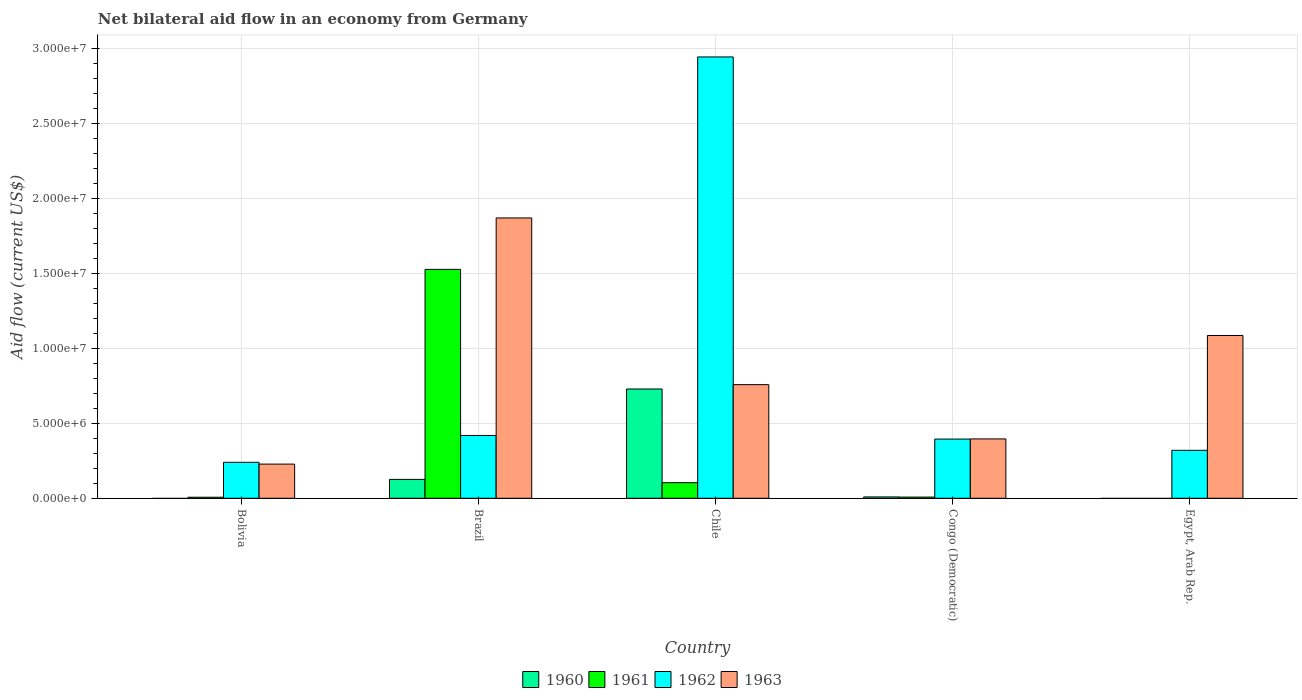How many different coloured bars are there?
Ensure brevity in your answer.  4. How many bars are there on the 3rd tick from the left?
Offer a terse response. 4. How many bars are there on the 4th tick from the right?
Provide a short and direct response. 4. What is the label of the 2nd group of bars from the left?
Keep it short and to the point. Brazil. In how many cases, is the number of bars for a given country not equal to the number of legend labels?
Your answer should be very brief. 2. What is the net bilateral aid flow in 1960 in Brazil?
Give a very brief answer. 1.26e+06. Across all countries, what is the maximum net bilateral aid flow in 1960?
Your answer should be very brief. 7.29e+06. Across all countries, what is the minimum net bilateral aid flow in 1960?
Your answer should be compact. 0. In which country was the net bilateral aid flow in 1962 maximum?
Your answer should be compact. Chile. What is the total net bilateral aid flow in 1963 in the graph?
Make the answer very short. 4.34e+07. What is the difference between the net bilateral aid flow in 1962 in Brazil and that in Egypt, Arab Rep.?
Keep it short and to the point. 9.90e+05. What is the difference between the net bilateral aid flow in 1961 in Chile and the net bilateral aid flow in 1963 in Egypt, Arab Rep.?
Ensure brevity in your answer.  -9.82e+06. What is the average net bilateral aid flow in 1963 per country?
Provide a short and direct response. 8.68e+06. What is the difference between the net bilateral aid flow of/in 1962 and net bilateral aid flow of/in 1961 in Chile?
Your answer should be very brief. 2.84e+07. In how many countries, is the net bilateral aid flow in 1961 greater than 16000000 US$?
Offer a terse response. 0. Is the net bilateral aid flow in 1962 in Congo (Democratic) less than that in Egypt, Arab Rep.?
Provide a succinct answer. No. Is the difference between the net bilateral aid flow in 1962 in Bolivia and Brazil greater than the difference between the net bilateral aid flow in 1961 in Bolivia and Brazil?
Your response must be concise. Yes. What is the difference between the highest and the second highest net bilateral aid flow in 1960?
Provide a succinct answer. 7.20e+06. What is the difference between the highest and the lowest net bilateral aid flow in 1962?
Your answer should be very brief. 2.70e+07. Is it the case that in every country, the sum of the net bilateral aid flow in 1962 and net bilateral aid flow in 1960 is greater than the net bilateral aid flow in 1963?
Ensure brevity in your answer.  No. How many countries are there in the graph?
Offer a terse response. 5. Does the graph contain any zero values?
Your answer should be compact. Yes. Where does the legend appear in the graph?
Your answer should be compact. Bottom center. How are the legend labels stacked?
Keep it short and to the point. Horizontal. What is the title of the graph?
Your answer should be compact. Net bilateral aid flow in an economy from Germany. Does "2012" appear as one of the legend labels in the graph?
Provide a succinct answer. No. What is the label or title of the Y-axis?
Offer a terse response. Aid flow (current US$). What is the Aid flow (current US$) of 1961 in Bolivia?
Ensure brevity in your answer.  7.00e+04. What is the Aid flow (current US$) of 1962 in Bolivia?
Your answer should be compact. 2.40e+06. What is the Aid flow (current US$) of 1963 in Bolivia?
Ensure brevity in your answer.  2.28e+06. What is the Aid flow (current US$) in 1960 in Brazil?
Ensure brevity in your answer.  1.26e+06. What is the Aid flow (current US$) in 1961 in Brazil?
Offer a very short reply. 1.53e+07. What is the Aid flow (current US$) of 1962 in Brazil?
Your response must be concise. 4.19e+06. What is the Aid flow (current US$) of 1963 in Brazil?
Provide a short and direct response. 1.87e+07. What is the Aid flow (current US$) in 1960 in Chile?
Keep it short and to the point. 7.29e+06. What is the Aid flow (current US$) in 1961 in Chile?
Provide a succinct answer. 1.04e+06. What is the Aid flow (current US$) of 1962 in Chile?
Provide a short and direct response. 2.94e+07. What is the Aid flow (current US$) of 1963 in Chile?
Keep it short and to the point. 7.58e+06. What is the Aid flow (current US$) of 1962 in Congo (Democratic)?
Provide a short and direct response. 3.95e+06. What is the Aid flow (current US$) of 1963 in Congo (Democratic)?
Offer a very short reply. 3.96e+06. What is the Aid flow (current US$) of 1961 in Egypt, Arab Rep.?
Offer a terse response. 0. What is the Aid flow (current US$) in 1962 in Egypt, Arab Rep.?
Offer a terse response. 3.20e+06. What is the Aid flow (current US$) in 1963 in Egypt, Arab Rep.?
Give a very brief answer. 1.09e+07. Across all countries, what is the maximum Aid flow (current US$) in 1960?
Provide a succinct answer. 7.29e+06. Across all countries, what is the maximum Aid flow (current US$) of 1961?
Provide a short and direct response. 1.53e+07. Across all countries, what is the maximum Aid flow (current US$) in 1962?
Your response must be concise. 2.94e+07. Across all countries, what is the maximum Aid flow (current US$) of 1963?
Your answer should be very brief. 1.87e+07. Across all countries, what is the minimum Aid flow (current US$) in 1960?
Offer a very short reply. 0. Across all countries, what is the minimum Aid flow (current US$) of 1961?
Your answer should be compact. 0. Across all countries, what is the minimum Aid flow (current US$) of 1962?
Keep it short and to the point. 2.40e+06. Across all countries, what is the minimum Aid flow (current US$) of 1963?
Offer a terse response. 2.28e+06. What is the total Aid flow (current US$) of 1960 in the graph?
Ensure brevity in your answer.  8.64e+06. What is the total Aid flow (current US$) in 1961 in the graph?
Provide a short and direct response. 1.65e+07. What is the total Aid flow (current US$) of 1962 in the graph?
Give a very brief answer. 4.32e+07. What is the total Aid flow (current US$) of 1963 in the graph?
Offer a very short reply. 4.34e+07. What is the difference between the Aid flow (current US$) of 1961 in Bolivia and that in Brazil?
Offer a terse response. -1.52e+07. What is the difference between the Aid flow (current US$) in 1962 in Bolivia and that in Brazil?
Provide a short and direct response. -1.79e+06. What is the difference between the Aid flow (current US$) of 1963 in Bolivia and that in Brazil?
Offer a very short reply. -1.64e+07. What is the difference between the Aid flow (current US$) of 1961 in Bolivia and that in Chile?
Your answer should be very brief. -9.70e+05. What is the difference between the Aid flow (current US$) of 1962 in Bolivia and that in Chile?
Provide a succinct answer. -2.70e+07. What is the difference between the Aid flow (current US$) of 1963 in Bolivia and that in Chile?
Provide a succinct answer. -5.30e+06. What is the difference between the Aid flow (current US$) in 1962 in Bolivia and that in Congo (Democratic)?
Provide a short and direct response. -1.55e+06. What is the difference between the Aid flow (current US$) of 1963 in Bolivia and that in Congo (Democratic)?
Keep it short and to the point. -1.68e+06. What is the difference between the Aid flow (current US$) in 1962 in Bolivia and that in Egypt, Arab Rep.?
Offer a terse response. -8.00e+05. What is the difference between the Aid flow (current US$) of 1963 in Bolivia and that in Egypt, Arab Rep.?
Ensure brevity in your answer.  -8.58e+06. What is the difference between the Aid flow (current US$) in 1960 in Brazil and that in Chile?
Offer a very short reply. -6.03e+06. What is the difference between the Aid flow (current US$) of 1961 in Brazil and that in Chile?
Provide a short and direct response. 1.42e+07. What is the difference between the Aid flow (current US$) in 1962 in Brazil and that in Chile?
Ensure brevity in your answer.  -2.52e+07. What is the difference between the Aid flow (current US$) in 1963 in Brazil and that in Chile?
Your answer should be very brief. 1.11e+07. What is the difference between the Aid flow (current US$) in 1960 in Brazil and that in Congo (Democratic)?
Your answer should be compact. 1.17e+06. What is the difference between the Aid flow (current US$) in 1961 in Brazil and that in Congo (Democratic)?
Your answer should be very brief. 1.52e+07. What is the difference between the Aid flow (current US$) of 1963 in Brazil and that in Congo (Democratic)?
Ensure brevity in your answer.  1.47e+07. What is the difference between the Aid flow (current US$) in 1962 in Brazil and that in Egypt, Arab Rep.?
Provide a short and direct response. 9.90e+05. What is the difference between the Aid flow (current US$) of 1963 in Brazil and that in Egypt, Arab Rep.?
Keep it short and to the point. 7.84e+06. What is the difference between the Aid flow (current US$) in 1960 in Chile and that in Congo (Democratic)?
Give a very brief answer. 7.20e+06. What is the difference between the Aid flow (current US$) of 1961 in Chile and that in Congo (Democratic)?
Ensure brevity in your answer.  9.60e+05. What is the difference between the Aid flow (current US$) in 1962 in Chile and that in Congo (Democratic)?
Your response must be concise. 2.55e+07. What is the difference between the Aid flow (current US$) of 1963 in Chile and that in Congo (Democratic)?
Provide a succinct answer. 3.62e+06. What is the difference between the Aid flow (current US$) in 1962 in Chile and that in Egypt, Arab Rep.?
Offer a very short reply. 2.62e+07. What is the difference between the Aid flow (current US$) of 1963 in Chile and that in Egypt, Arab Rep.?
Keep it short and to the point. -3.28e+06. What is the difference between the Aid flow (current US$) of 1962 in Congo (Democratic) and that in Egypt, Arab Rep.?
Ensure brevity in your answer.  7.50e+05. What is the difference between the Aid flow (current US$) of 1963 in Congo (Democratic) and that in Egypt, Arab Rep.?
Offer a very short reply. -6.90e+06. What is the difference between the Aid flow (current US$) of 1961 in Bolivia and the Aid flow (current US$) of 1962 in Brazil?
Offer a very short reply. -4.12e+06. What is the difference between the Aid flow (current US$) of 1961 in Bolivia and the Aid flow (current US$) of 1963 in Brazil?
Keep it short and to the point. -1.86e+07. What is the difference between the Aid flow (current US$) in 1962 in Bolivia and the Aid flow (current US$) in 1963 in Brazil?
Your answer should be very brief. -1.63e+07. What is the difference between the Aid flow (current US$) in 1961 in Bolivia and the Aid flow (current US$) in 1962 in Chile?
Ensure brevity in your answer.  -2.94e+07. What is the difference between the Aid flow (current US$) of 1961 in Bolivia and the Aid flow (current US$) of 1963 in Chile?
Your answer should be compact. -7.51e+06. What is the difference between the Aid flow (current US$) in 1962 in Bolivia and the Aid flow (current US$) in 1963 in Chile?
Give a very brief answer. -5.18e+06. What is the difference between the Aid flow (current US$) of 1961 in Bolivia and the Aid flow (current US$) of 1962 in Congo (Democratic)?
Provide a succinct answer. -3.88e+06. What is the difference between the Aid flow (current US$) of 1961 in Bolivia and the Aid flow (current US$) of 1963 in Congo (Democratic)?
Give a very brief answer. -3.89e+06. What is the difference between the Aid flow (current US$) of 1962 in Bolivia and the Aid flow (current US$) of 1963 in Congo (Democratic)?
Offer a very short reply. -1.56e+06. What is the difference between the Aid flow (current US$) in 1961 in Bolivia and the Aid flow (current US$) in 1962 in Egypt, Arab Rep.?
Provide a succinct answer. -3.13e+06. What is the difference between the Aid flow (current US$) of 1961 in Bolivia and the Aid flow (current US$) of 1963 in Egypt, Arab Rep.?
Keep it short and to the point. -1.08e+07. What is the difference between the Aid flow (current US$) of 1962 in Bolivia and the Aid flow (current US$) of 1963 in Egypt, Arab Rep.?
Your answer should be very brief. -8.46e+06. What is the difference between the Aid flow (current US$) of 1960 in Brazil and the Aid flow (current US$) of 1962 in Chile?
Offer a terse response. -2.82e+07. What is the difference between the Aid flow (current US$) in 1960 in Brazil and the Aid flow (current US$) in 1963 in Chile?
Offer a very short reply. -6.32e+06. What is the difference between the Aid flow (current US$) in 1961 in Brazil and the Aid flow (current US$) in 1962 in Chile?
Give a very brief answer. -1.42e+07. What is the difference between the Aid flow (current US$) of 1961 in Brazil and the Aid flow (current US$) of 1963 in Chile?
Your answer should be compact. 7.69e+06. What is the difference between the Aid flow (current US$) in 1962 in Brazil and the Aid flow (current US$) in 1963 in Chile?
Your answer should be very brief. -3.39e+06. What is the difference between the Aid flow (current US$) of 1960 in Brazil and the Aid flow (current US$) of 1961 in Congo (Democratic)?
Provide a short and direct response. 1.18e+06. What is the difference between the Aid flow (current US$) in 1960 in Brazil and the Aid flow (current US$) in 1962 in Congo (Democratic)?
Offer a very short reply. -2.69e+06. What is the difference between the Aid flow (current US$) of 1960 in Brazil and the Aid flow (current US$) of 1963 in Congo (Democratic)?
Provide a succinct answer. -2.70e+06. What is the difference between the Aid flow (current US$) of 1961 in Brazil and the Aid flow (current US$) of 1962 in Congo (Democratic)?
Your response must be concise. 1.13e+07. What is the difference between the Aid flow (current US$) in 1961 in Brazil and the Aid flow (current US$) in 1963 in Congo (Democratic)?
Ensure brevity in your answer.  1.13e+07. What is the difference between the Aid flow (current US$) of 1962 in Brazil and the Aid flow (current US$) of 1963 in Congo (Democratic)?
Provide a short and direct response. 2.30e+05. What is the difference between the Aid flow (current US$) in 1960 in Brazil and the Aid flow (current US$) in 1962 in Egypt, Arab Rep.?
Make the answer very short. -1.94e+06. What is the difference between the Aid flow (current US$) of 1960 in Brazil and the Aid flow (current US$) of 1963 in Egypt, Arab Rep.?
Provide a short and direct response. -9.60e+06. What is the difference between the Aid flow (current US$) in 1961 in Brazil and the Aid flow (current US$) in 1962 in Egypt, Arab Rep.?
Give a very brief answer. 1.21e+07. What is the difference between the Aid flow (current US$) in 1961 in Brazil and the Aid flow (current US$) in 1963 in Egypt, Arab Rep.?
Give a very brief answer. 4.41e+06. What is the difference between the Aid flow (current US$) of 1962 in Brazil and the Aid flow (current US$) of 1963 in Egypt, Arab Rep.?
Offer a very short reply. -6.67e+06. What is the difference between the Aid flow (current US$) of 1960 in Chile and the Aid flow (current US$) of 1961 in Congo (Democratic)?
Keep it short and to the point. 7.21e+06. What is the difference between the Aid flow (current US$) in 1960 in Chile and the Aid flow (current US$) in 1962 in Congo (Democratic)?
Ensure brevity in your answer.  3.34e+06. What is the difference between the Aid flow (current US$) in 1960 in Chile and the Aid flow (current US$) in 1963 in Congo (Democratic)?
Your answer should be very brief. 3.33e+06. What is the difference between the Aid flow (current US$) in 1961 in Chile and the Aid flow (current US$) in 1962 in Congo (Democratic)?
Your response must be concise. -2.91e+06. What is the difference between the Aid flow (current US$) of 1961 in Chile and the Aid flow (current US$) of 1963 in Congo (Democratic)?
Ensure brevity in your answer.  -2.92e+06. What is the difference between the Aid flow (current US$) of 1962 in Chile and the Aid flow (current US$) of 1963 in Congo (Democratic)?
Provide a short and direct response. 2.55e+07. What is the difference between the Aid flow (current US$) of 1960 in Chile and the Aid flow (current US$) of 1962 in Egypt, Arab Rep.?
Make the answer very short. 4.09e+06. What is the difference between the Aid flow (current US$) in 1960 in Chile and the Aid flow (current US$) in 1963 in Egypt, Arab Rep.?
Offer a very short reply. -3.57e+06. What is the difference between the Aid flow (current US$) in 1961 in Chile and the Aid flow (current US$) in 1962 in Egypt, Arab Rep.?
Offer a terse response. -2.16e+06. What is the difference between the Aid flow (current US$) in 1961 in Chile and the Aid flow (current US$) in 1963 in Egypt, Arab Rep.?
Your response must be concise. -9.82e+06. What is the difference between the Aid flow (current US$) in 1962 in Chile and the Aid flow (current US$) in 1963 in Egypt, Arab Rep.?
Provide a short and direct response. 1.86e+07. What is the difference between the Aid flow (current US$) of 1960 in Congo (Democratic) and the Aid flow (current US$) of 1962 in Egypt, Arab Rep.?
Give a very brief answer. -3.11e+06. What is the difference between the Aid flow (current US$) of 1960 in Congo (Democratic) and the Aid flow (current US$) of 1963 in Egypt, Arab Rep.?
Give a very brief answer. -1.08e+07. What is the difference between the Aid flow (current US$) in 1961 in Congo (Democratic) and the Aid flow (current US$) in 1962 in Egypt, Arab Rep.?
Make the answer very short. -3.12e+06. What is the difference between the Aid flow (current US$) in 1961 in Congo (Democratic) and the Aid flow (current US$) in 1963 in Egypt, Arab Rep.?
Your response must be concise. -1.08e+07. What is the difference between the Aid flow (current US$) in 1962 in Congo (Democratic) and the Aid flow (current US$) in 1963 in Egypt, Arab Rep.?
Provide a succinct answer. -6.91e+06. What is the average Aid flow (current US$) of 1960 per country?
Offer a terse response. 1.73e+06. What is the average Aid flow (current US$) of 1961 per country?
Offer a very short reply. 3.29e+06. What is the average Aid flow (current US$) in 1962 per country?
Provide a succinct answer. 8.64e+06. What is the average Aid flow (current US$) in 1963 per country?
Ensure brevity in your answer.  8.68e+06. What is the difference between the Aid flow (current US$) in 1961 and Aid flow (current US$) in 1962 in Bolivia?
Keep it short and to the point. -2.33e+06. What is the difference between the Aid flow (current US$) in 1961 and Aid flow (current US$) in 1963 in Bolivia?
Provide a short and direct response. -2.21e+06. What is the difference between the Aid flow (current US$) in 1960 and Aid flow (current US$) in 1961 in Brazil?
Offer a terse response. -1.40e+07. What is the difference between the Aid flow (current US$) of 1960 and Aid flow (current US$) of 1962 in Brazil?
Your response must be concise. -2.93e+06. What is the difference between the Aid flow (current US$) of 1960 and Aid flow (current US$) of 1963 in Brazil?
Ensure brevity in your answer.  -1.74e+07. What is the difference between the Aid flow (current US$) of 1961 and Aid flow (current US$) of 1962 in Brazil?
Offer a very short reply. 1.11e+07. What is the difference between the Aid flow (current US$) in 1961 and Aid flow (current US$) in 1963 in Brazil?
Your answer should be compact. -3.43e+06. What is the difference between the Aid flow (current US$) in 1962 and Aid flow (current US$) in 1963 in Brazil?
Provide a succinct answer. -1.45e+07. What is the difference between the Aid flow (current US$) in 1960 and Aid flow (current US$) in 1961 in Chile?
Ensure brevity in your answer.  6.25e+06. What is the difference between the Aid flow (current US$) of 1960 and Aid flow (current US$) of 1962 in Chile?
Offer a terse response. -2.22e+07. What is the difference between the Aid flow (current US$) of 1961 and Aid flow (current US$) of 1962 in Chile?
Keep it short and to the point. -2.84e+07. What is the difference between the Aid flow (current US$) of 1961 and Aid flow (current US$) of 1963 in Chile?
Your response must be concise. -6.54e+06. What is the difference between the Aid flow (current US$) of 1962 and Aid flow (current US$) of 1963 in Chile?
Your response must be concise. 2.19e+07. What is the difference between the Aid flow (current US$) of 1960 and Aid flow (current US$) of 1962 in Congo (Democratic)?
Give a very brief answer. -3.86e+06. What is the difference between the Aid flow (current US$) in 1960 and Aid flow (current US$) in 1963 in Congo (Democratic)?
Give a very brief answer. -3.87e+06. What is the difference between the Aid flow (current US$) of 1961 and Aid flow (current US$) of 1962 in Congo (Democratic)?
Provide a succinct answer. -3.87e+06. What is the difference between the Aid flow (current US$) of 1961 and Aid flow (current US$) of 1963 in Congo (Democratic)?
Ensure brevity in your answer.  -3.88e+06. What is the difference between the Aid flow (current US$) of 1962 and Aid flow (current US$) of 1963 in Congo (Democratic)?
Make the answer very short. -10000. What is the difference between the Aid flow (current US$) of 1962 and Aid flow (current US$) of 1963 in Egypt, Arab Rep.?
Offer a terse response. -7.66e+06. What is the ratio of the Aid flow (current US$) in 1961 in Bolivia to that in Brazil?
Your answer should be very brief. 0. What is the ratio of the Aid flow (current US$) of 1962 in Bolivia to that in Brazil?
Your answer should be very brief. 0.57. What is the ratio of the Aid flow (current US$) in 1963 in Bolivia to that in Brazil?
Your response must be concise. 0.12. What is the ratio of the Aid flow (current US$) in 1961 in Bolivia to that in Chile?
Give a very brief answer. 0.07. What is the ratio of the Aid flow (current US$) in 1962 in Bolivia to that in Chile?
Provide a short and direct response. 0.08. What is the ratio of the Aid flow (current US$) in 1963 in Bolivia to that in Chile?
Your answer should be compact. 0.3. What is the ratio of the Aid flow (current US$) in 1961 in Bolivia to that in Congo (Democratic)?
Your response must be concise. 0.88. What is the ratio of the Aid flow (current US$) in 1962 in Bolivia to that in Congo (Democratic)?
Offer a terse response. 0.61. What is the ratio of the Aid flow (current US$) of 1963 in Bolivia to that in Congo (Democratic)?
Your answer should be very brief. 0.58. What is the ratio of the Aid flow (current US$) of 1962 in Bolivia to that in Egypt, Arab Rep.?
Your answer should be very brief. 0.75. What is the ratio of the Aid flow (current US$) of 1963 in Bolivia to that in Egypt, Arab Rep.?
Give a very brief answer. 0.21. What is the ratio of the Aid flow (current US$) of 1960 in Brazil to that in Chile?
Keep it short and to the point. 0.17. What is the ratio of the Aid flow (current US$) of 1961 in Brazil to that in Chile?
Offer a very short reply. 14.68. What is the ratio of the Aid flow (current US$) in 1962 in Brazil to that in Chile?
Offer a terse response. 0.14. What is the ratio of the Aid flow (current US$) in 1963 in Brazil to that in Chile?
Make the answer very short. 2.47. What is the ratio of the Aid flow (current US$) in 1960 in Brazil to that in Congo (Democratic)?
Keep it short and to the point. 14. What is the ratio of the Aid flow (current US$) of 1961 in Brazil to that in Congo (Democratic)?
Your answer should be compact. 190.88. What is the ratio of the Aid flow (current US$) in 1962 in Brazil to that in Congo (Democratic)?
Your response must be concise. 1.06. What is the ratio of the Aid flow (current US$) of 1963 in Brazil to that in Congo (Democratic)?
Offer a terse response. 4.72. What is the ratio of the Aid flow (current US$) of 1962 in Brazil to that in Egypt, Arab Rep.?
Keep it short and to the point. 1.31. What is the ratio of the Aid flow (current US$) in 1963 in Brazil to that in Egypt, Arab Rep.?
Make the answer very short. 1.72. What is the ratio of the Aid flow (current US$) in 1961 in Chile to that in Congo (Democratic)?
Your response must be concise. 13. What is the ratio of the Aid flow (current US$) in 1962 in Chile to that in Congo (Democratic)?
Your answer should be compact. 7.45. What is the ratio of the Aid flow (current US$) of 1963 in Chile to that in Congo (Democratic)?
Provide a short and direct response. 1.91. What is the ratio of the Aid flow (current US$) of 1963 in Chile to that in Egypt, Arab Rep.?
Your answer should be compact. 0.7. What is the ratio of the Aid flow (current US$) of 1962 in Congo (Democratic) to that in Egypt, Arab Rep.?
Offer a very short reply. 1.23. What is the ratio of the Aid flow (current US$) in 1963 in Congo (Democratic) to that in Egypt, Arab Rep.?
Your answer should be compact. 0.36. What is the difference between the highest and the second highest Aid flow (current US$) in 1960?
Provide a succinct answer. 6.03e+06. What is the difference between the highest and the second highest Aid flow (current US$) in 1961?
Provide a short and direct response. 1.42e+07. What is the difference between the highest and the second highest Aid flow (current US$) in 1962?
Provide a succinct answer. 2.52e+07. What is the difference between the highest and the second highest Aid flow (current US$) in 1963?
Ensure brevity in your answer.  7.84e+06. What is the difference between the highest and the lowest Aid flow (current US$) of 1960?
Make the answer very short. 7.29e+06. What is the difference between the highest and the lowest Aid flow (current US$) of 1961?
Your answer should be compact. 1.53e+07. What is the difference between the highest and the lowest Aid flow (current US$) in 1962?
Make the answer very short. 2.70e+07. What is the difference between the highest and the lowest Aid flow (current US$) in 1963?
Your answer should be compact. 1.64e+07. 